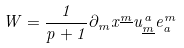Convert formula to latex. <formula><loc_0><loc_0><loc_500><loc_500>W = { \frac { 1 } { p + 1 } } \partial _ { m } x ^ { \underline { m } } u _ { \underline { m } } ^ { a } e _ { a } ^ { m }</formula> 